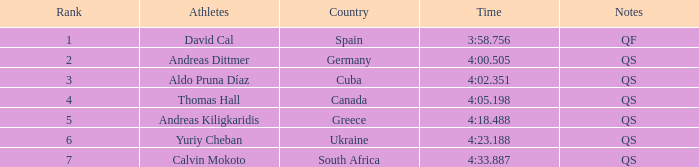What are the remarks for the competitor from south africa? QS. 